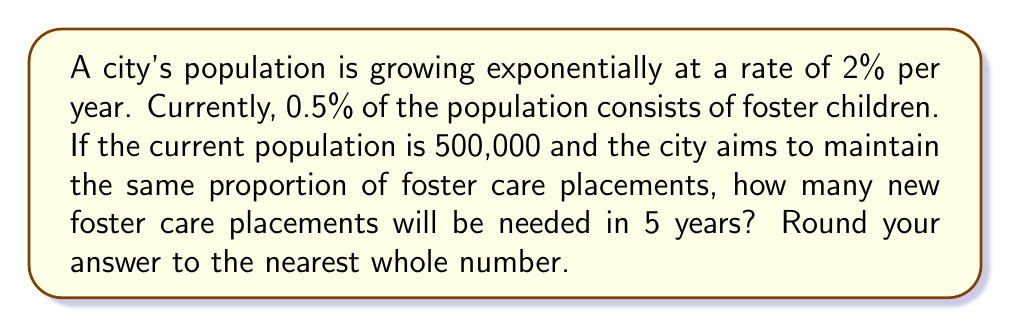What is the answer to this math problem? Let's approach this step-by-step:

1) First, we need to calculate the population after 5 years. The formula for exponential growth is:

   $$P(t) = P_0 \cdot e^{rt}$$

   Where:
   $P(t)$ is the population at time $t$
   $P_0$ is the initial population
   $r$ is the growth rate
   $t$ is the time in years

2) We have:
   $P_0 = 500,000$
   $r = 0.02$ (2% = 0.02)
   $t = 5$

3) Plugging these into our formula:

   $$P(5) = 500,000 \cdot e^{0.02 \cdot 5}$$

4) Calculating:
   
   $$P(5) = 500,000 \cdot e^{0.1} \approx 552,786$$

5) Now, we need to calculate the number of foster children in 5 years:

   $$552,786 \cdot 0.005 = 2,763.93$$

6) To find the number of new placements, we subtract the current number of foster children:

   Current foster children: $500,000 \cdot 0.005 = 2,500$

   New placements: $2,763.93 - 2,500 = 263.93$

7) Rounding to the nearest whole number:

   $$264$$
Answer: 264 